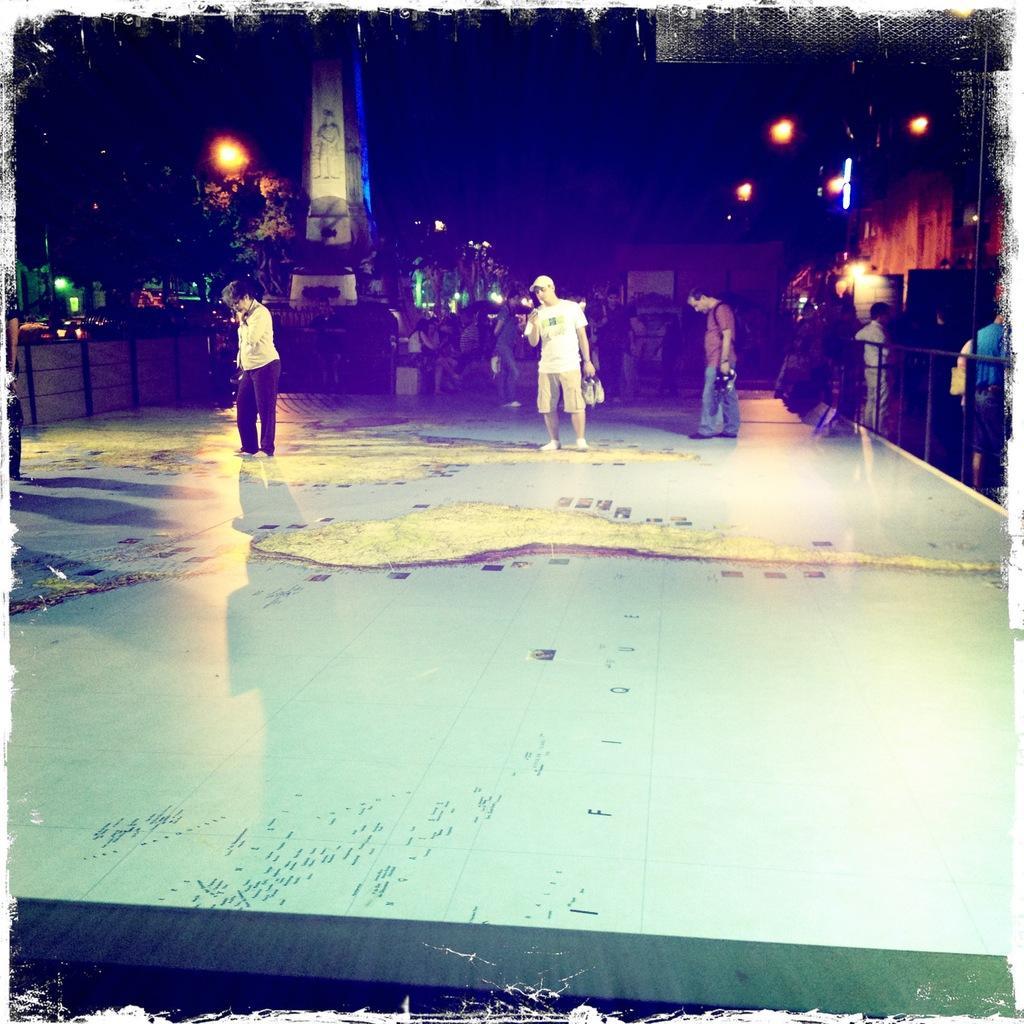How would you summarize this image in a sentence or two? In this image there are a few people standing and walking on the floor, behind them there are few people sitting. On the right side of the image there is a railing, beside the railing there are a few people standing. In the background there are trees, buildings and lights. 